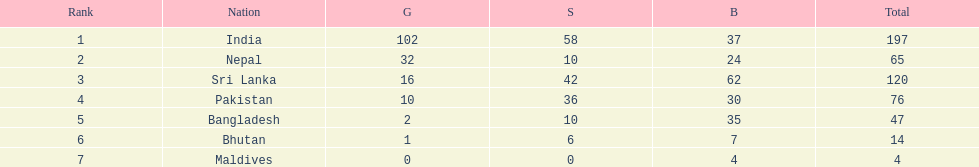What was the number of silver medals won by pakistan? 36. 